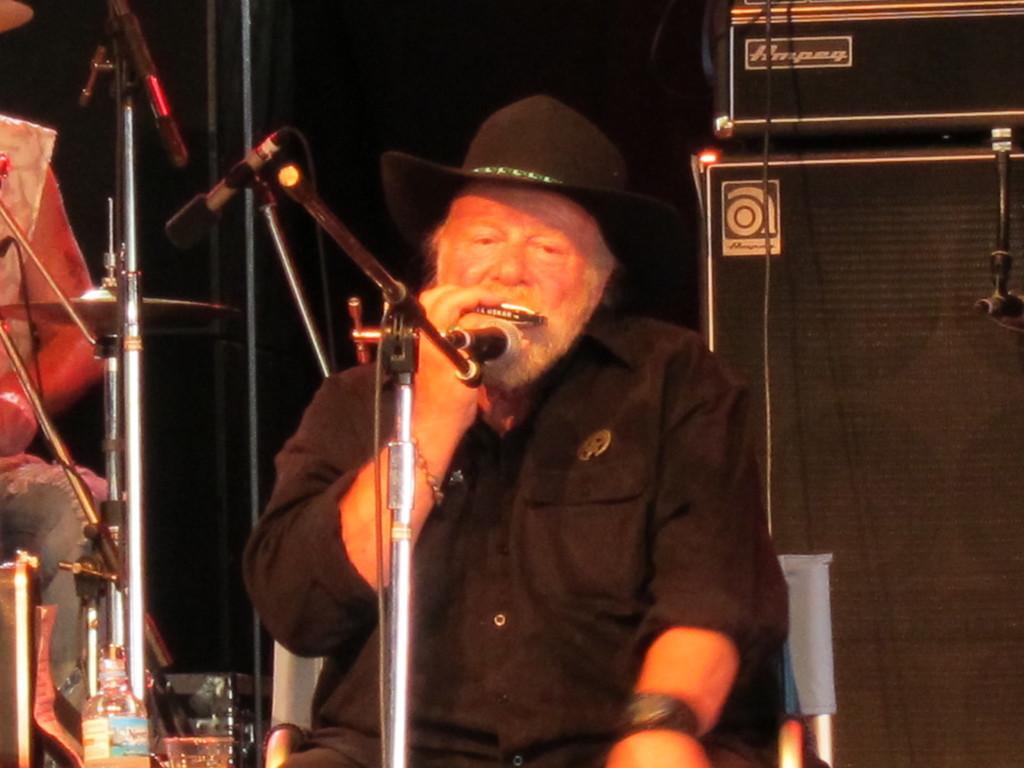Can you describe this image briefly? An old man is sitting in a chair wearing a cap and he is playing some musical instrument in front a microphone, behind him there are a speakers and a black curtain, beside him there is another person and a bottle is there. 